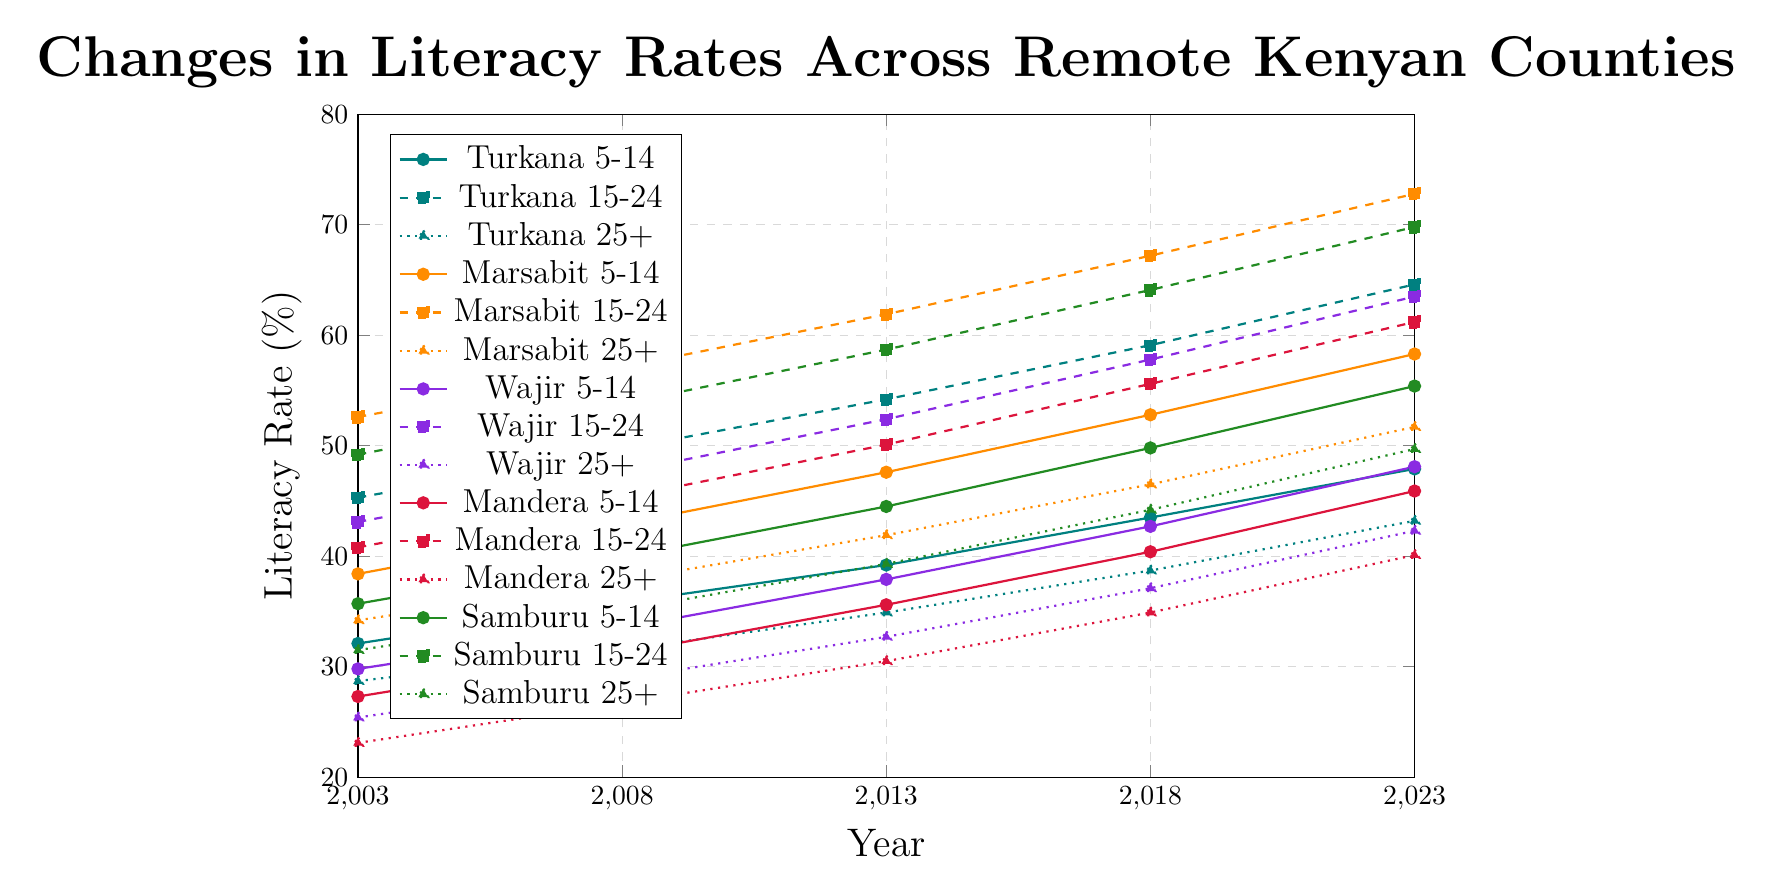What is the literacy rate for the age group 15-24 years in Mandera County in 2023? To find the literacy rate for the age group 15-24 years in Mandera County in 2023, locate the corresponding plot line for Mandera 15-24 years and look at the value on the y-axis for the year 2023.
Answer: 61.2 Which county had the highest literacy rate for the 5-14 years age group in 2023? Identify the plot lines for all counties for the 5-14 years age group and compare their values in 2023. The county with the highest value is Marsabit.
Answer: Marsabit How has the literacy rate for the age group 25+ in Turkana County changed from 2003 to 2023? To evaluate this, check the plot line for Turkana 25+ and note the values in 2003 and 2023. Subtract the 2003 value from the 2023 value: 43.2 - 28.7 = 14.5.
Answer: Increased by 14.5 Between 2003 and 2023, which age group in Wajir County saw the biggest increase in literacy rates? Compare the increments for all age groups in Wajir County from 2003 to 2023. Calculate the change for each group: 
- 5-14 years: 48.1 - 29.8 = 18.3 
- 15-24 years: 63.5 - 43.1 = 20.4 
- 25+ years: 42.3 - 25.4 = 16.9 
The biggest increase is for 15-24 years.
Answer: 15-24 years Comparing Turkana and Samburu, which county had a higher literacy rate for the 15-24 years age group in 2018? Find the values for both Turkana and Samburu for the age group 15-24 years in 2018 from their respective plot lines. Turkana has 59.1 and Samburu has 64.1.
Answer: Samburu What is the difference in literacy rates between the 15-24 years and 25+ years age groups in Marsabit County in 2023? Identify the literacy rates for Marsabit's 15-24 and 25+ age groups in 2023. Subtract the 25+ value from the 15-24 value: 72.8 - 51.7 = 21.1.
Answer: 21.1 Which county has the steepest upward trend for the 5-14 years age group? Compare the slopes of the plot lines for all counties for the 5-14 years age group. Marsabit shows the steepest increase from 38.4 in 2003 to 58.3 in 2023, a change of 19.9.
Answer: Marsabit What is the average literacy rate for the age group 25+ in Samburu County over the 20 years? To find the average, add the values for Samburu 25+ in the years provided and divide by the number of years: (31.5 + 35.1 + 39.3 + 44.2 + 49.7) / 5 = 39.96.
Answer: 39.96 